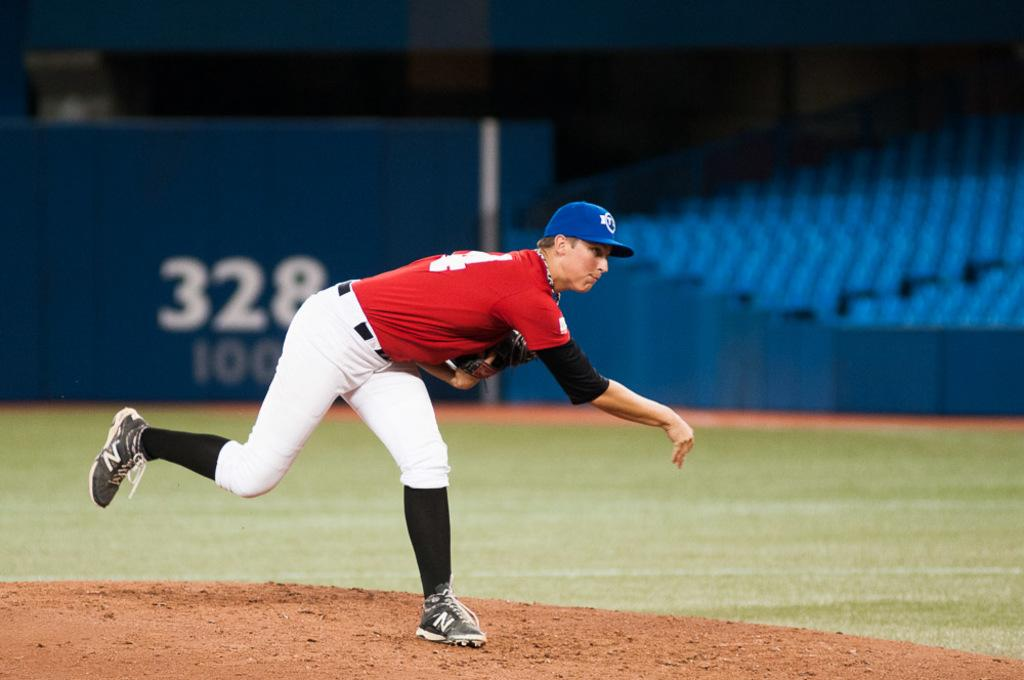<image>
Give a short and clear explanation of the subsequent image. A baseball player with the number 328 behind him. 